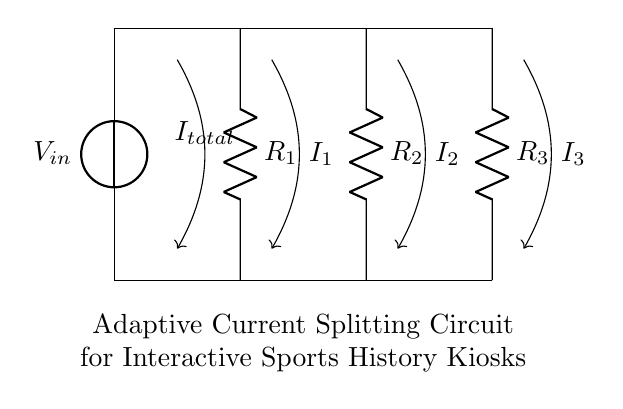What is the total current in the circuit? The total current is denoted as I_total, shown by the arrow pointing down from the voltage source. This indicates the main current flowing through the circuit before it divides.
Answer: I_total What types of resistors are used in this circuit? The circuit diagram shows three resistors labeled R_1, R_2, and R_3. These resistors are connected in parallel, each contributing to the current splitting functionality of the circuit.
Answer: R_1, R_2, R_3 How many branches does the current divide into? The circuit shows three paths where the total current splits: through R_1, R_2, and R_3. This branching indicates that there are three distinct paths for the current to flow through after it leaves the voltage source.
Answer: Three What is the relationship between the resistors in this current divider? In a current divider configuration, the current flowing through each resistor is inversely proportional to its resistance value. This means that a lower resistance will allow more current to flow through it compared to a higher resistance, making it a key characteristic of how the resistors interact in the circuit.
Answer: Inversely proportional What can be inferred about the voltage across each resistor? In this arrangement, the voltage across each resistor remains the same as they are in parallel. Thus, each resistor experiences the same voltage as the source voltage, enabling a consistent voltage application in the current division process.
Answer: Same as V_in 